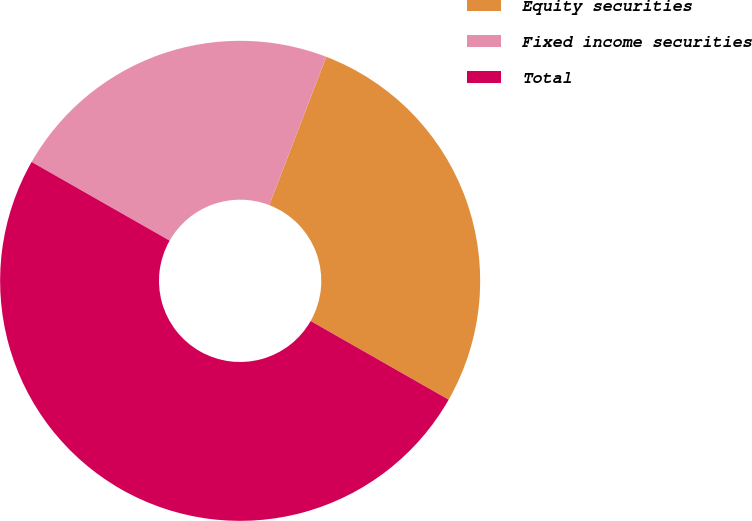Convert chart. <chart><loc_0><loc_0><loc_500><loc_500><pie_chart><fcel>Equity securities<fcel>Fixed income securities<fcel>Total<nl><fcel>27.4%<fcel>22.6%<fcel>50.0%<nl></chart> 